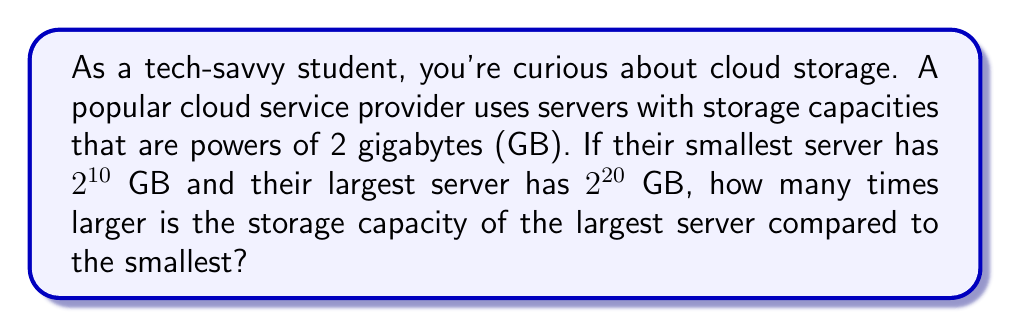Can you answer this question? Let's approach this step-by-step:

1) The smallest server has a capacity of $2^{10}$ GB
2) The largest server has a capacity of $2^{20}$ GB

To find how many times larger the largest server is, we need to divide the larger capacity by the smaller:

$$\frac{\text{Largest server capacity}}{\text{Smallest server capacity}} = \frac{2^{20}}{2^{10}}$$

We can simplify this using the laws of exponents. When dividing powers with the same base, we subtract the exponents:

$$\frac{2^{20}}{2^{10}} = 2^{20-10} = 2^{10}$$

Now, let's calculate $2^{10}$:

$$2^{10} = 1024$$

Therefore, the largest server is 1024 times larger than the smallest server.

This showcases how exponential growth in data storage can lead to massive differences in capacity, which is crucial for understanding modern cloud infrastructure.
Answer: The largest server is $2^{10} = 1024$ times larger than the smallest server. 